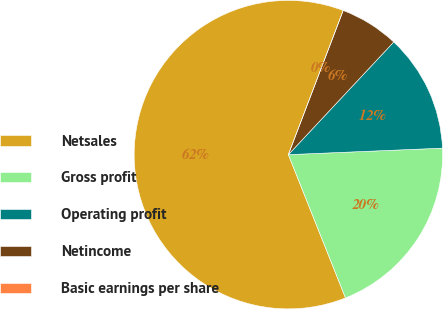Convert chart to OTSL. <chart><loc_0><loc_0><loc_500><loc_500><pie_chart><fcel>Netsales<fcel>Gross profit<fcel>Operating profit<fcel>Netincome<fcel>Basic earnings per share<nl><fcel>61.82%<fcel>19.63%<fcel>12.36%<fcel>6.18%<fcel>0.0%<nl></chart> 